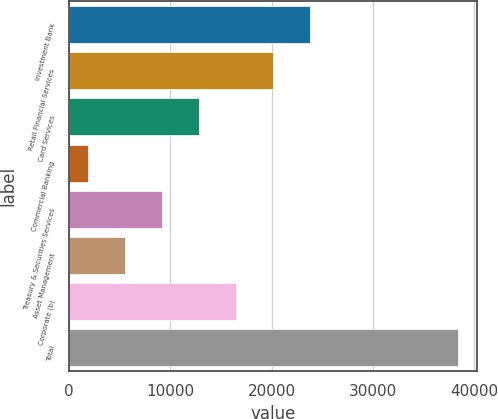Convert chart to OTSL. <chart><loc_0><loc_0><loc_500><loc_500><bar_chart><fcel>Investment Bank<fcel>Retail Financial Services<fcel>Card Services<fcel>Commercial Banking<fcel>Treasury & Securities Services<fcel>Asset Management<fcel>Corporate (b)<fcel>Total<nl><fcel>23798<fcel>20141<fcel>12827<fcel>1856<fcel>9170<fcel>5513<fcel>16484<fcel>38426<nl></chart> 